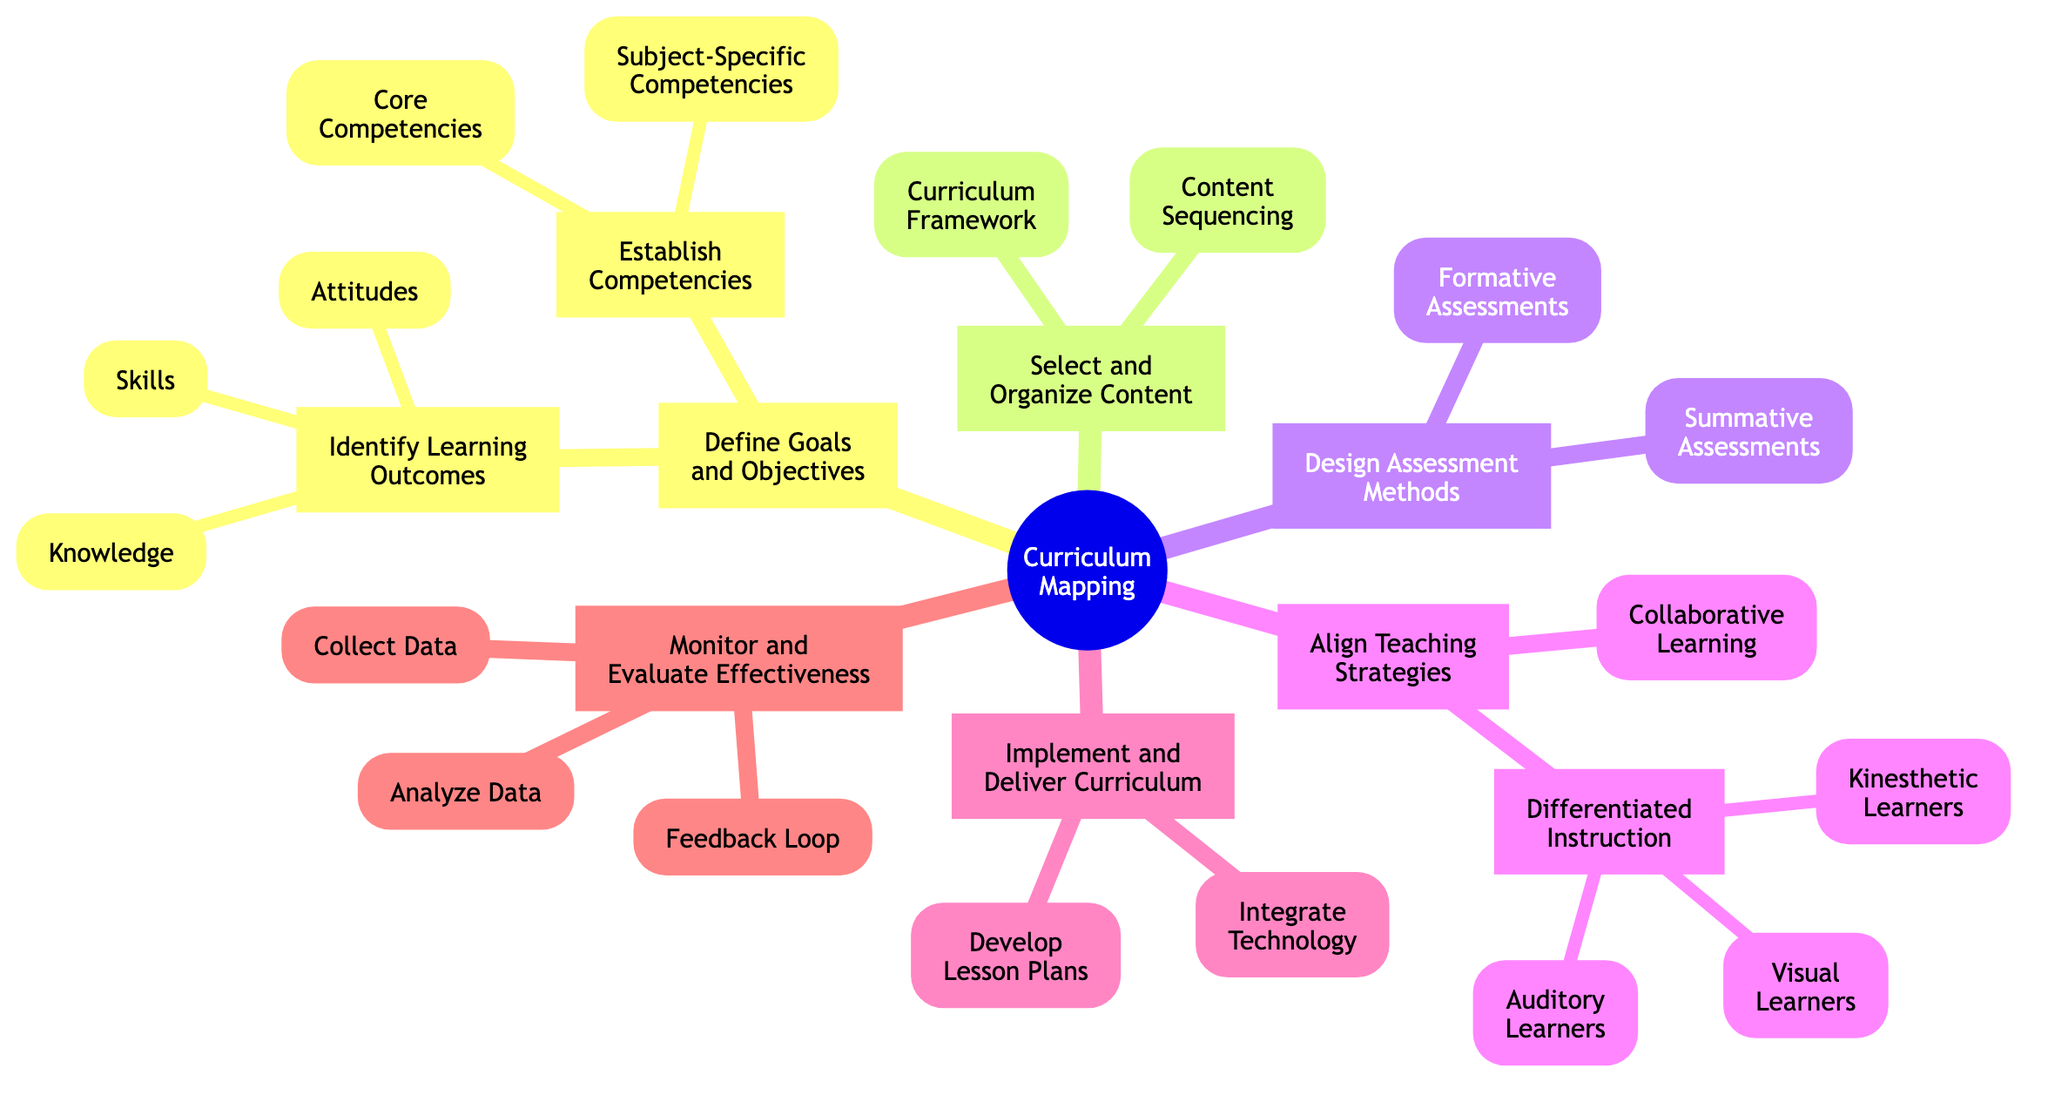What is the first step in curriculum mapping? The first step visible in the mind map is "Define Goals and Objectives." This is clearly indicated as the starting node under "Curriculum Mapping."
Answer: Define Goals and Objectives How many main steps are there in the curriculum mapping process? The diagram shows six main steps branching out from the root node "Curriculum Mapping." Each step is distinctly listed as a separate node.
Answer: 6 What type of assessments are included in "Design Assessment Methods"? Under "Design Assessment Methods," there are two types of assessments mentioned: "Formative Assessments" and "Summative Assessments." Each is represented as a sub-node, clearly showing their inclusion in this step.
Answer: Formative Assessments, Summative Assessments Which teaching strategy is associated with different learning styles? The strategy associated with different learning styles is "Differentiated Instruction," which includes nodes for Visual Learners, Auditory Learners, and Kinesthetic Learners. This indicates that the approach tailors to specific learning preferences.
Answer: Differentiated Instruction What do you need to do in the "Monitor and Evaluate Effectiveness" step? In the "Monitor and Evaluate Effectiveness" step, the actions required are "Collect Data," "Analyze Data," and "Feedback Loop," as shown in the respective sub-nodes under this main step.
Answer: Collect Data, Analyze Data, Feedback Loop How are "Knowledge," "Skills," and "Attitudes" categorized? They are categorized under the node "Identify Learning Outcomes," indicating that these three elements are part of defining what students should learn as identified outcomes.
Answer: Identify Learning Outcomes What is a key component of the "Implement and Deliver Curriculum" step? A key component under "Implement and Deliver Curriculum" is "Develop Lesson Plans," which indicates the necessity of creating structured plans to deliver the curriculum effectively.
Answer: Develop Lesson Plans What are the core competencies? Core competencies refer to "Essential abilities all students should develop," indicating a focus on fundamental skills that should be prioritized across the curriculum. This classification appears under "Establish Competencies."
Answer: Essential abilities all students should develop In which main step would you find content sequencing? Content sequencing is found in the main step "Select and Organize Content," as indicated in the corresponding sub-node. This suggests that organizing content logically is crucial to the curriculum mapping process.
Answer: Select and Organize Content 